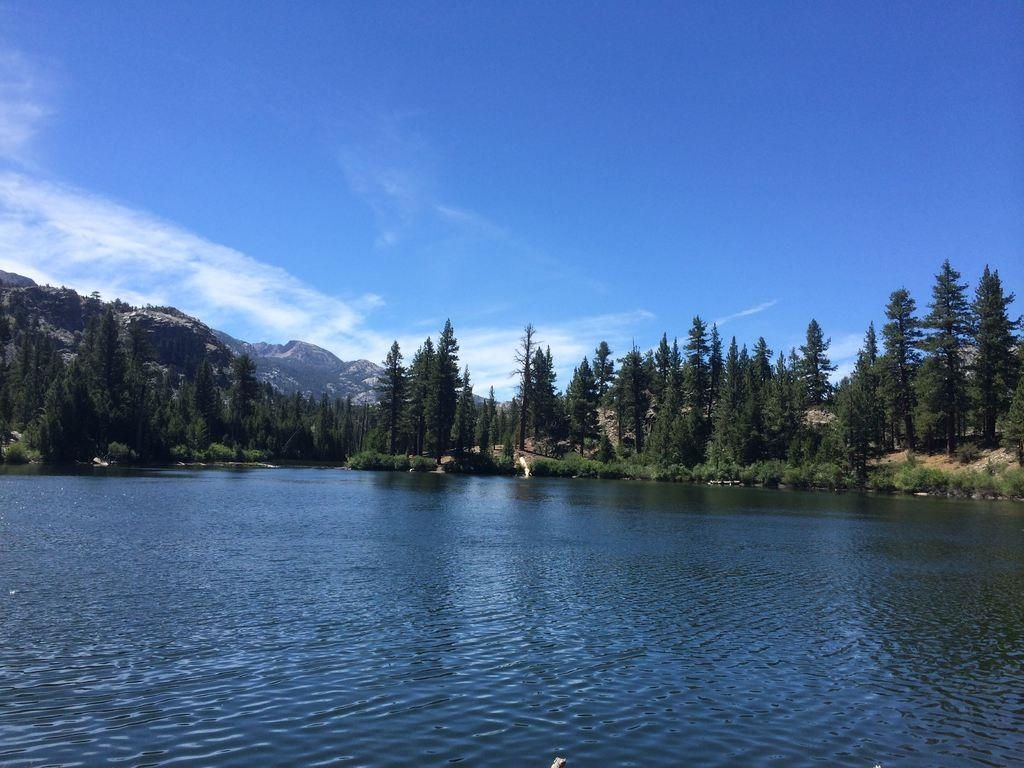What natural element is visible in the image? Water is visible in the image. What type of vegetation can be seen in the image? Grass, plants, and trees can be seen in the image. What geographical feature is present in the image? There are hills in the image. What part of the natural environment is visible in the image? The sky is visible in the image. What hobbies are the plants participating in during the day in the image? Plants do not have hobbies, as they are living organisms and not capable of participating in hobbies. What songs are the hills singing in the image? Hills do not sing songs, as they are geographical features and not capable of singing songs. 